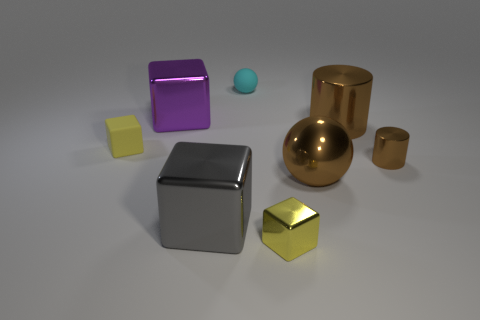Is there a block made of the same material as the small cyan thing?
Your answer should be very brief. Yes. Is there a big brown metallic sphere in front of the brown cylinder in front of the small yellow rubber object?
Offer a very short reply. Yes. What is the material of the small yellow block on the left side of the cyan matte sphere?
Ensure brevity in your answer.  Rubber. Does the purple object have the same shape as the cyan matte object?
Offer a very short reply. No. What color is the large metallic cube that is behind the tiny yellow block that is behind the yellow block right of the small yellow rubber object?
Keep it short and to the point. Purple. How many tiny brown shiny objects have the same shape as the small cyan matte thing?
Your answer should be compact. 0. How big is the sphere that is behind the metal cube that is left of the gray cube?
Provide a succinct answer. Small. Does the purple thing have the same size as the brown ball?
Your answer should be very brief. Yes. Is there a small ball behind the tiny matte object on the right side of the tiny yellow cube behind the small brown metal thing?
Your response must be concise. No. What size is the gray thing?
Give a very brief answer. Large. 